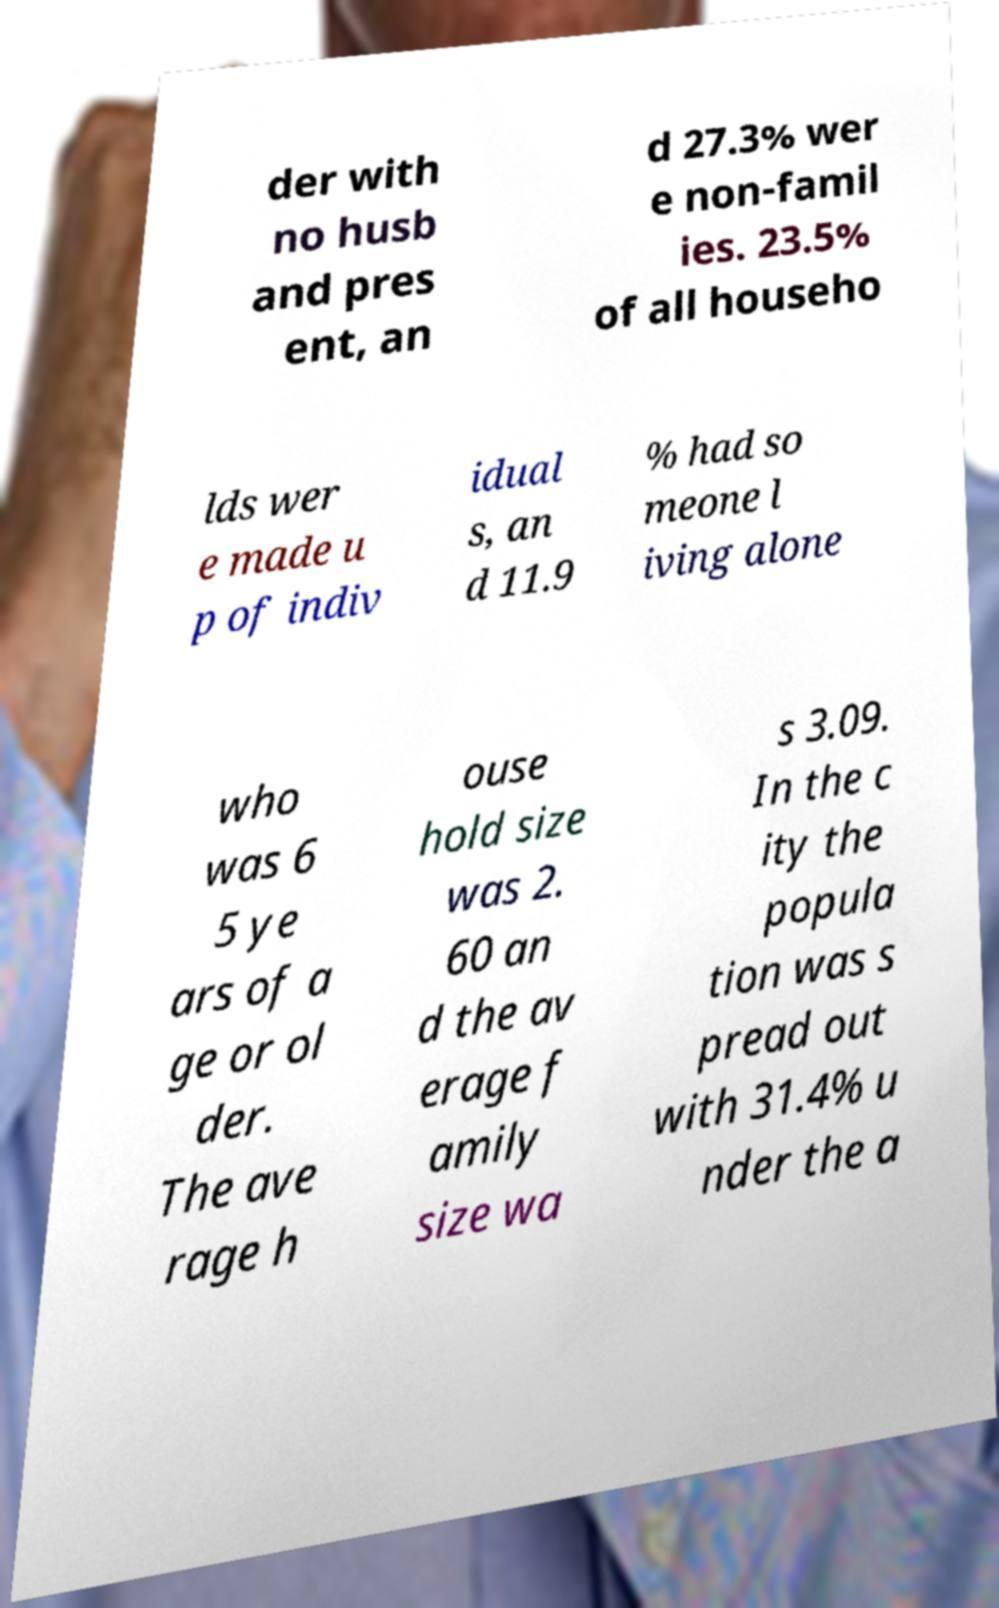Could you assist in decoding the text presented in this image and type it out clearly? der with no husb and pres ent, an d 27.3% wer e non-famil ies. 23.5% of all househo lds wer e made u p of indiv idual s, an d 11.9 % had so meone l iving alone who was 6 5 ye ars of a ge or ol der. The ave rage h ouse hold size was 2. 60 an d the av erage f amily size wa s 3.09. In the c ity the popula tion was s pread out with 31.4% u nder the a 